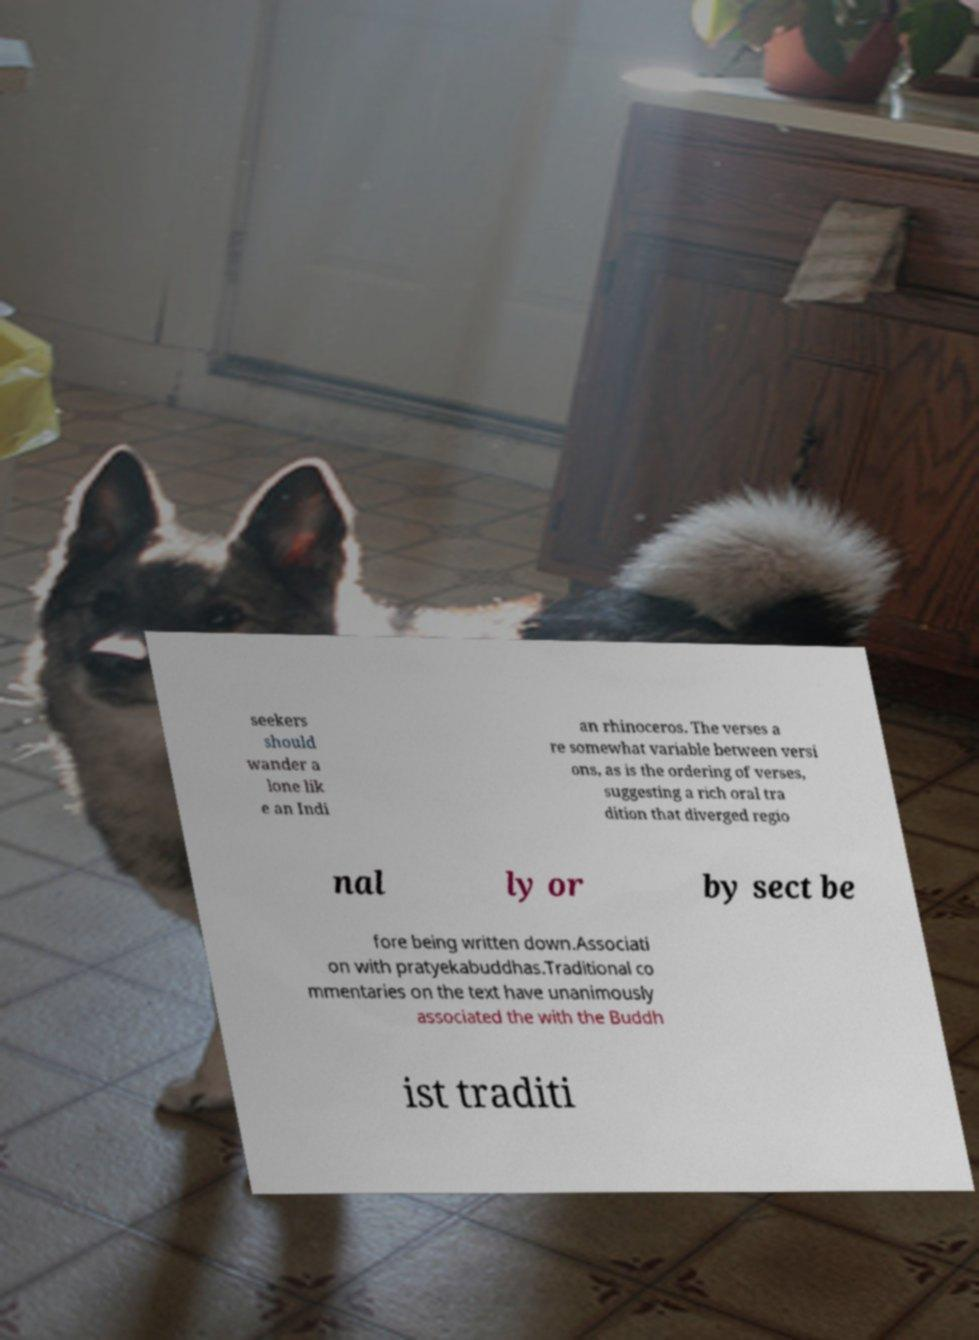Can you accurately transcribe the text from the provided image for me? seekers should wander a lone lik e an Indi an rhinoceros. The verses a re somewhat variable between versi ons, as is the ordering of verses, suggesting a rich oral tra dition that diverged regio nal ly or by sect be fore being written down.Associati on with pratyekabuddhas.Traditional co mmentaries on the text have unanimously associated the with the Buddh ist traditi 